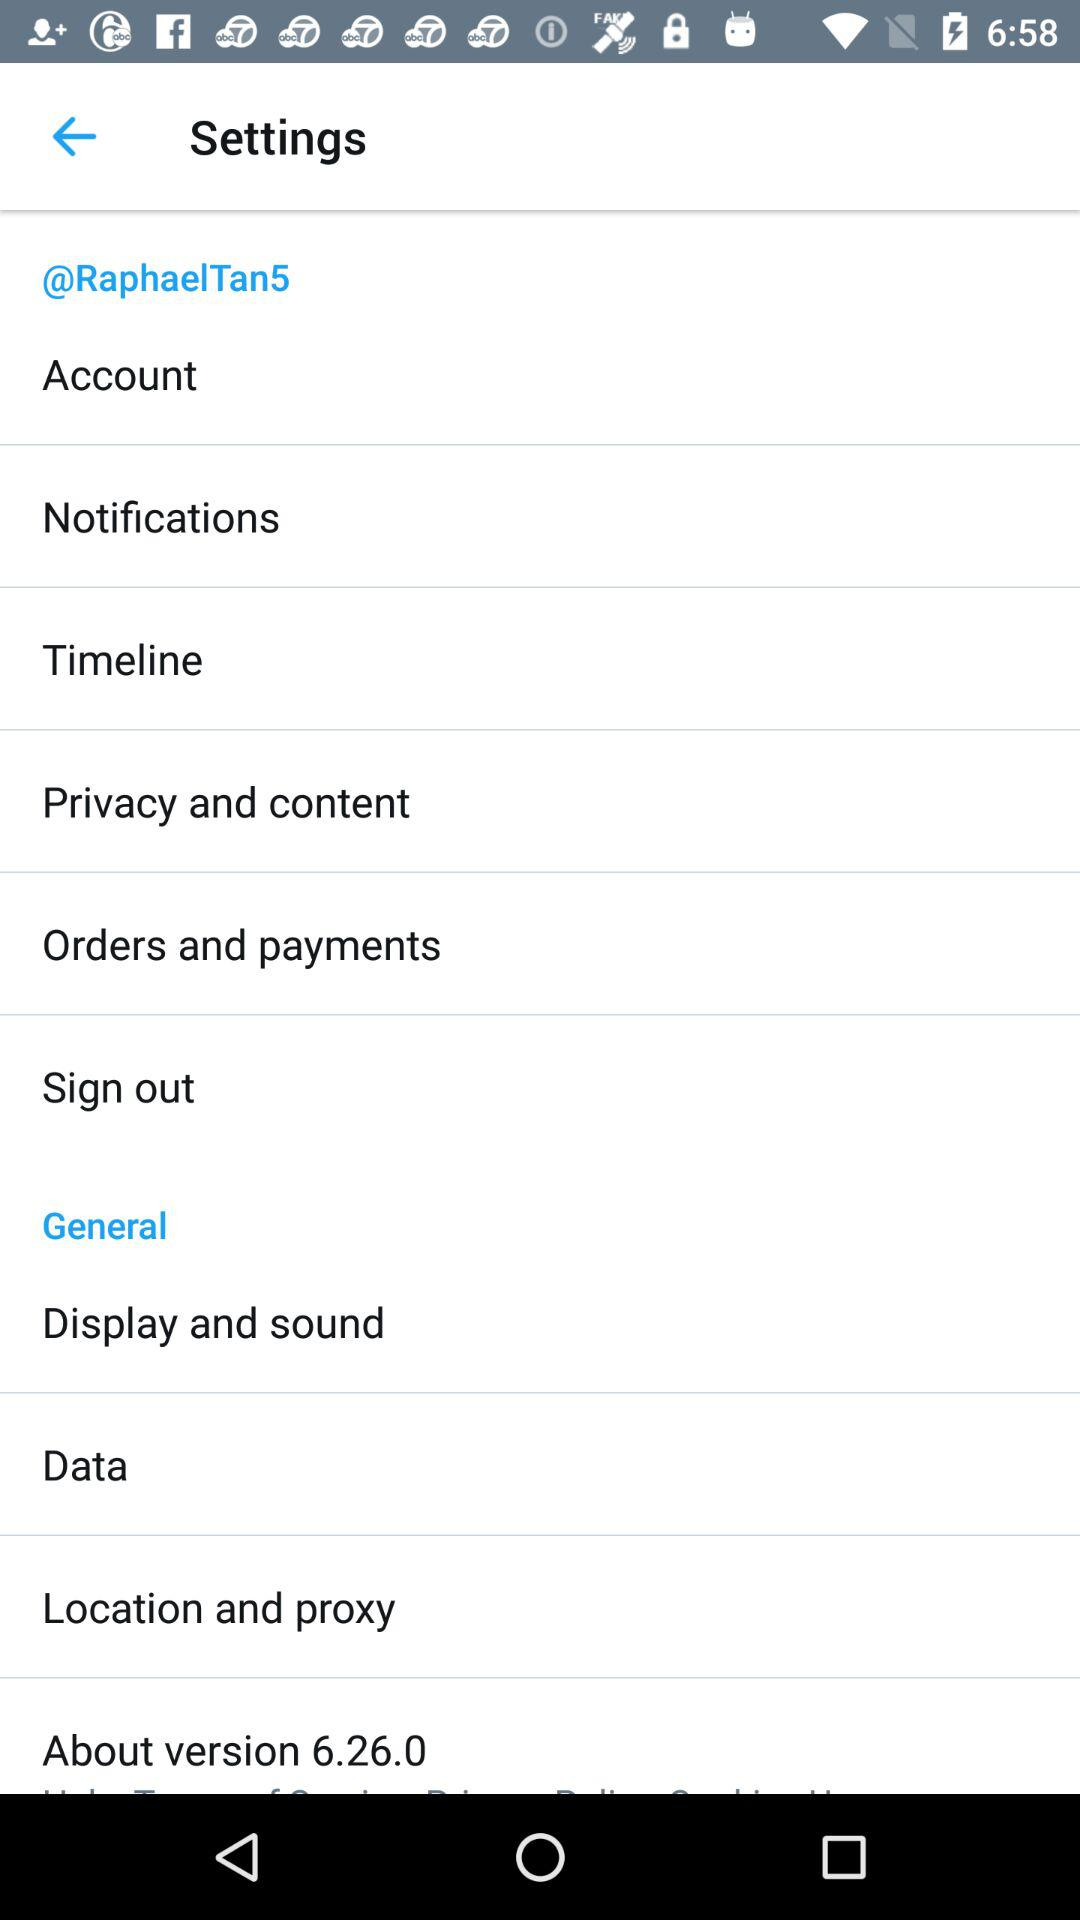Which version is it? The version is 6.26.0. 